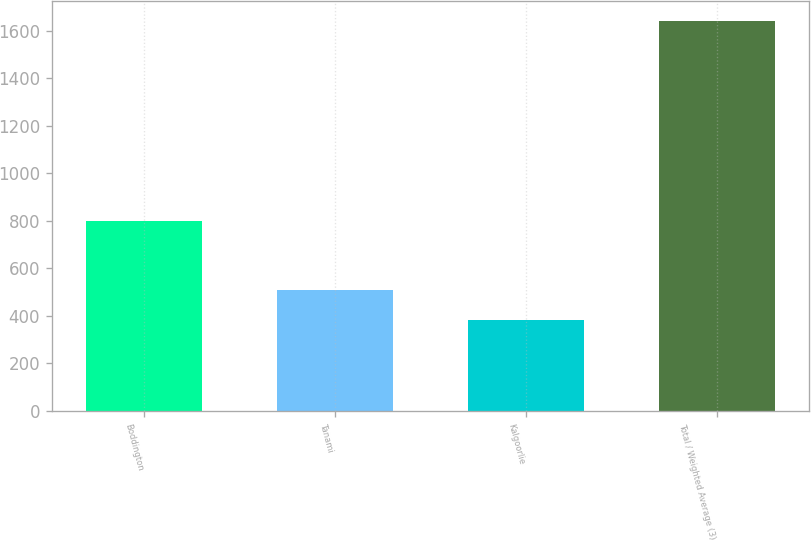Convert chart. <chart><loc_0><loc_0><loc_500><loc_500><bar_chart><fcel>Boddington<fcel>Tanami<fcel>Kalgoorlie<fcel>Total / Weighted Average (3)<nl><fcel>800<fcel>507.9<fcel>382<fcel>1641<nl></chart> 